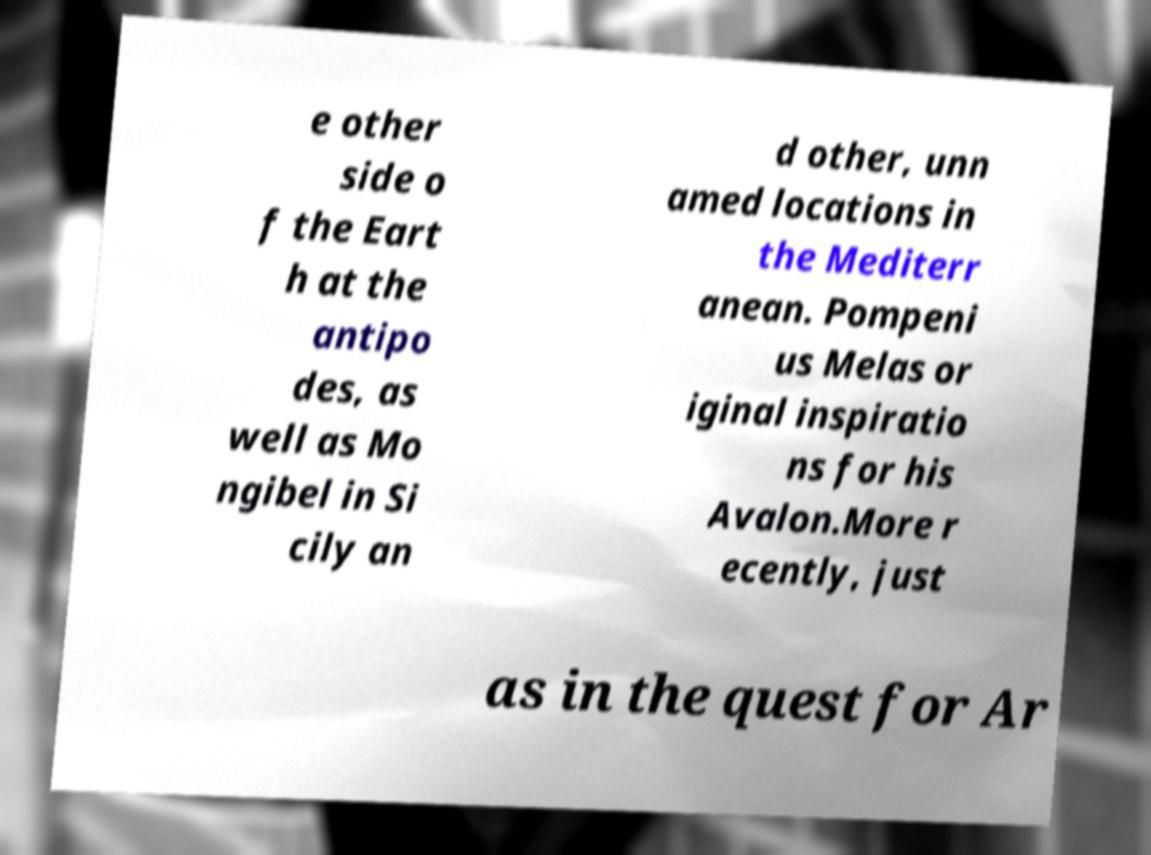Can you accurately transcribe the text from the provided image for me? e other side o f the Eart h at the antipo des, as well as Mo ngibel in Si cily an d other, unn amed locations in the Mediterr anean. Pompeni us Melas or iginal inspiratio ns for his Avalon.More r ecently, just as in the quest for Ar 